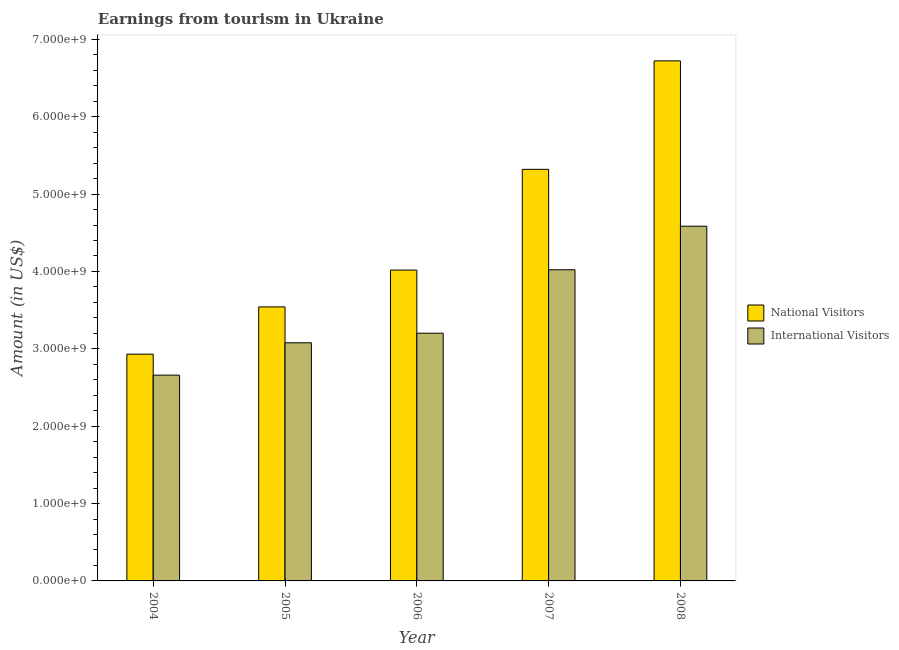How many groups of bars are there?
Give a very brief answer. 5. Are the number of bars on each tick of the X-axis equal?
Offer a very short reply. Yes. How many bars are there on the 4th tick from the left?
Your answer should be compact. 2. What is the amount earned from national visitors in 2006?
Your response must be concise. 4.02e+09. Across all years, what is the maximum amount earned from national visitors?
Make the answer very short. 6.72e+09. Across all years, what is the minimum amount earned from national visitors?
Your response must be concise. 2.93e+09. In which year was the amount earned from international visitors maximum?
Ensure brevity in your answer.  2008. In which year was the amount earned from international visitors minimum?
Offer a very short reply. 2004. What is the total amount earned from national visitors in the graph?
Keep it short and to the point. 2.25e+1. What is the difference between the amount earned from national visitors in 2007 and that in 2008?
Ensure brevity in your answer.  -1.40e+09. What is the difference between the amount earned from national visitors in 2005 and the amount earned from international visitors in 2008?
Offer a terse response. -3.18e+09. What is the average amount earned from national visitors per year?
Make the answer very short. 4.51e+09. In how many years, is the amount earned from national visitors greater than 1200000000 US$?
Keep it short and to the point. 5. What is the ratio of the amount earned from international visitors in 2006 to that in 2008?
Keep it short and to the point. 0.7. Is the amount earned from international visitors in 2004 less than that in 2005?
Give a very brief answer. Yes. What is the difference between the highest and the second highest amount earned from national visitors?
Keep it short and to the point. 1.40e+09. What is the difference between the highest and the lowest amount earned from national visitors?
Offer a very short reply. 3.79e+09. In how many years, is the amount earned from national visitors greater than the average amount earned from national visitors taken over all years?
Offer a terse response. 2. Is the sum of the amount earned from national visitors in 2005 and 2006 greater than the maximum amount earned from international visitors across all years?
Your answer should be very brief. Yes. What does the 1st bar from the left in 2007 represents?
Give a very brief answer. National Visitors. What does the 2nd bar from the right in 2006 represents?
Offer a terse response. National Visitors. How many bars are there?
Your answer should be compact. 10. How many years are there in the graph?
Make the answer very short. 5. Are the values on the major ticks of Y-axis written in scientific E-notation?
Offer a very short reply. Yes. Does the graph contain grids?
Give a very brief answer. No. Where does the legend appear in the graph?
Your answer should be compact. Center right. What is the title of the graph?
Offer a very short reply. Earnings from tourism in Ukraine. Does "Time to export" appear as one of the legend labels in the graph?
Offer a very short reply. No. What is the label or title of the X-axis?
Give a very brief answer. Year. What is the Amount (in US$) in National Visitors in 2004?
Your response must be concise. 2.93e+09. What is the Amount (in US$) in International Visitors in 2004?
Your answer should be compact. 2.66e+09. What is the Amount (in US$) in National Visitors in 2005?
Ensure brevity in your answer.  3.54e+09. What is the Amount (in US$) in International Visitors in 2005?
Provide a succinct answer. 3.08e+09. What is the Amount (in US$) of National Visitors in 2006?
Offer a terse response. 4.02e+09. What is the Amount (in US$) of International Visitors in 2006?
Your answer should be very brief. 3.20e+09. What is the Amount (in US$) of National Visitors in 2007?
Offer a terse response. 5.32e+09. What is the Amount (in US$) in International Visitors in 2007?
Make the answer very short. 4.02e+09. What is the Amount (in US$) in National Visitors in 2008?
Your answer should be compact. 6.72e+09. What is the Amount (in US$) in International Visitors in 2008?
Give a very brief answer. 4.58e+09. Across all years, what is the maximum Amount (in US$) in National Visitors?
Your response must be concise. 6.72e+09. Across all years, what is the maximum Amount (in US$) in International Visitors?
Your answer should be compact. 4.58e+09. Across all years, what is the minimum Amount (in US$) of National Visitors?
Offer a very short reply. 2.93e+09. Across all years, what is the minimum Amount (in US$) in International Visitors?
Your answer should be compact. 2.66e+09. What is the total Amount (in US$) in National Visitors in the graph?
Ensure brevity in your answer.  2.25e+1. What is the total Amount (in US$) of International Visitors in the graph?
Your answer should be compact. 1.75e+1. What is the difference between the Amount (in US$) in National Visitors in 2004 and that in 2005?
Keep it short and to the point. -6.11e+08. What is the difference between the Amount (in US$) of International Visitors in 2004 and that in 2005?
Make the answer very short. -4.18e+08. What is the difference between the Amount (in US$) of National Visitors in 2004 and that in 2006?
Offer a terse response. -1.09e+09. What is the difference between the Amount (in US$) in International Visitors in 2004 and that in 2006?
Offer a very short reply. -5.42e+08. What is the difference between the Amount (in US$) in National Visitors in 2004 and that in 2007?
Keep it short and to the point. -2.39e+09. What is the difference between the Amount (in US$) in International Visitors in 2004 and that in 2007?
Keep it short and to the point. -1.36e+09. What is the difference between the Amount (in US$) of National Visitors in 2004 and that in 2008?
Your answer should be compact. -3.79e+09. What is the difference between the Amount (in US$) of International Visitors in 2004 and that in 2008?
Provide a succinct answer. -1.92e+09. What is the difference between the Amount (in US$) of National Visitors in 2005 and that in 2006?
Keep it short and to the point. -4.76e+08. What is the difference between the Amount (in US$) in International Visitors in 2005 and that in 2006?
Offer a very short reply. -1.24e+08. What is the difference between the Amount (in US$) of National Visitors in 2005 and that in 2007?
Provide a succinct answer. -1.78e+09. What is the difference between the Amount (in US$) in International Visitors in 2005 and that in 2007?
Offer a very short reply. -9.44e+08. What is the difference between the Amount (in US$) of National Visitors in 2005 and that in 2008?
Offer a very short reply. -3.18e+09. What is the difference between the Amount (in US$) of International Visitors in 2005 and that in 2008?
Provide a succinct answer. -1.51e+09. What is the difference between the Amount (in US$) in National Visitors in 2006 and that in 2007?
Offer a terse response. -1.30e+09. What is the difference between the Amount (in US$) in International Visitors in 2006 and that in 2007?
Your response must be concise. -8.20e+08. What is the difference between the Amount (in US$) of National Visitors in 2006 and that in 2008?
Keep it short and to the point. -2.70e+09. What is the difference between the Amount (in US$) in International Visitors in 2006 and that in 2008?
Make the answer very short. -1.38e+09. What is the difference between the Amount (in US$) of National Visitors in 2007 and that in 2008?
Provide a succinct answer. -1.40e+09. What is the difference between the Amount (in US$) of International Visitors in 2007 and that in 2008?
Your answer should be compact. -5.63e+08. What is the difference between the Amount (in US$) of National Visitors in 2004 and the Amount (in US$) of International Visitors in 2005?
Keep it short and to the point. -1.47e+08. What is the difference between the Amount (in US$) in National Visitors in 2004 and the Amount (in US$) in International Visitors in 2006?
Ensure brevity in your answer.  -2.71e+08. What is the difference between the Amount (in US$) of National Visitors in 2004 and the Amount (in US$) of International Visitors in 2007?
Provide a short and direct response. -1.09e+09. What is the difference between the Amount (in US$) of National Visitors in 2004 and the Amount (in US$) of International Visitors in 2008?
Provide a short and direct response. -1.65e+09. What is the difference between the Amount (in US$) of National Visitors in 2005 and the Amount (in US$) of International Visitors in 2006?
Ensure brevity in your answer.  3.40e+08. What is the difference between the Amount (in US$) in National Visitors in 2005 and the Amount (in US$) in International Visitors in 2007?
Ensure brevity in your answer.  -4.80e+08. What is the difference between the Amount (in US$) in National Visitors in 2005 and the Amount (in US$) in International Visitors in 2008?
Offer a terse response. -1.04e+09. What is the difference between the Amount (in US$) of National Visitors in 2006 and the Amount (in US$) of International Visitors in 2007?
Your answer should be compact. -4.00e+06. What is the difference between the Amount (in US$) of National Visitors in 2006 and the Amount (in US$) of International Visitors in 2008?
Keep it short and to the point. -5.67e+08. What is the difference between the Amount (in US$) of National Visitors in 2007 and the Amount (in US$) of International Visitors in 2008?
Make the answer very short. 7.35e+08. What is the average Amount (in US$) of National Visitors per year?
Provide a short and direct response. 4.51e+09. What is the average Amount (in US$) in International Visitors per year?
Give a very brief answer. 3.51e+09. In the year 2004, what is the difference between the Amount (in US$) of National Visitors and Amount (in US$) of International Visitors?
Give a very brief answer. 2.71e+08. In the year 2005, what is the difference between the Amount (in US$) of National Visitors and Amount (in US$) of International Visitors?
Make the answer very short. 4.64e+08. In the year 2006, what is the difference between the Amount (in US$) in National Visitors and Amount (in US$) in International Visitors?
Your answer should be very brief. 8.16e+08. In the year 2007, what is the difference between the Amount (in US$) in National Visitors and Amount (in US$) in International Visitors?
Your response must be concise. 1.30e+09. In the year 2008, what is the difference between the Amount (in US$) in National Visitors and Amount (in US$) in International Visitors?
Give a very brief answer. 2.14e+09. What is the ratio of the Amount (in US$) in National Visitors in 2004 to that in 2005?
Provide a short and direct response. 0.83. What is the ratio of the Amount (in US$) in International Visitors in 2004 to that in 2005?
Make the answer very short. 0.86. What is the ratio of the Amount (in US$) in National Visitors in 2004 to that in 2006?
Give a very brief answer. 0.73. What is the ratio of the Amount (in US$) of International Visitors in 2004 to that in 2006?
Provide a succinct answer. 0.83. What is the ratio of the Amount (in US$) in National Visitors in 2004 to that in 2007?
Make the answer very short. 0.55. What is the ratio of the Amount (in US$) in International Visitors in 2004 to that in 2007?
Provide a short and direct response. 0.66. What is the ratio of the Amount (in US$) in National Visitors in 2004 to that in 2008?
Make the answer very short. 0.44. What is the ratio of the Amount (in US$) of International Visitors in 2004 to that in 2008?
Offer a very short reply. 0.58. What is the ratio of the Amount (in US$) in National Visitors in 2005 to that in 2006?
Make the answer very short. 0.88. What is the ratio of the Amount (in US$) in International Visitors in 2005 to that in 2006?
Give a very brief answer. 0.96. What is the ratio of the Amount (in US$) in National Visitors in 2005 to that in 2007?
Offer a very short reply. 0.67. What is the ratio of the Amount (in US$) of International Visitors in 2005 to that in 2007?
Offer a terse response. 0.77. What is the ratio of the Amount (in US$) in National Visitors in 2005 to that in 2008?
Ensure brevity in your answer.  0.53. What is the ratio of the Amount (in US$) of International Visitors in 2005 to that in 2008?
Offer a terse response. 0.67. What is the ratio of the Amount (in US$) in National Visitors in 2006 to that in 2007?
Keep it short and to the point. 0.76. What is the ratio of the Amount (in US$) in International Visitors in 2006 to that in 2007?
Provide a succinct answer. 0.8. What is the ratio of the Amount (in US$) in National Visitors in 2006 to that in 2008?
Offer a very short reply. 0.6. What is the ratio of the Amount (in US$) of International Visitors in 2006 to that in 2008?
Keep it short and to the point. 0.7. What is the ratio of the Amount (in US$) of National Visitors in 2007 to that in 2008?
Give a very brief answer. 0.79. What is the ratio of the Amount (in US$) of International Visitors in 2007 to that in 2008?
Make the answer very short. 0.88. What is the difference between the highest and the second highest Amount (in US$) in National Visitors?
Your answer should be compact. 1.40e+09. What is the difference between the highest and the second highest Amount (in US$) of International Visitors?
Your answer should be very brief. 5.63e+08. What is the difference between the highest and the lowest Amount (in US$) of National Visitors?
Your response must be concise. 3.79e+09. What is the difference between the highest and the lowest Amount (in US$) in International Visitors?
Provide a succinct answer. 1.92e+09. 